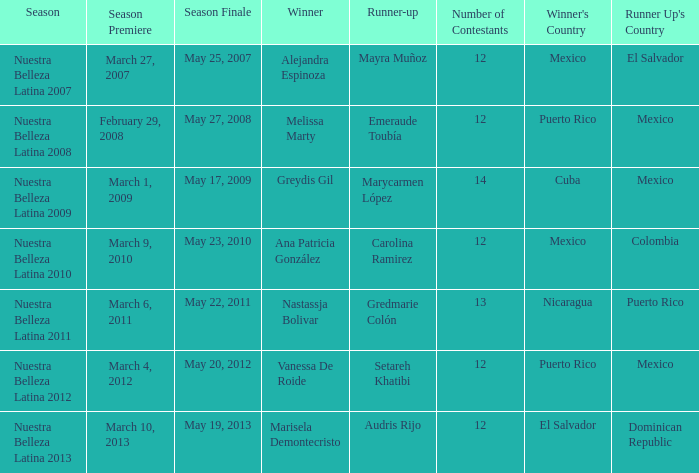What season's premiere had puerto rico winning on May 20, 2012? March 4, 2012. 